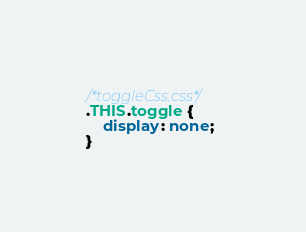<code> <loc_0><loc_0><loc_500><loc_500><_CSS_>/*toggleCss.css*/
.THIS.toggle {
    display: none;
}
</code> 